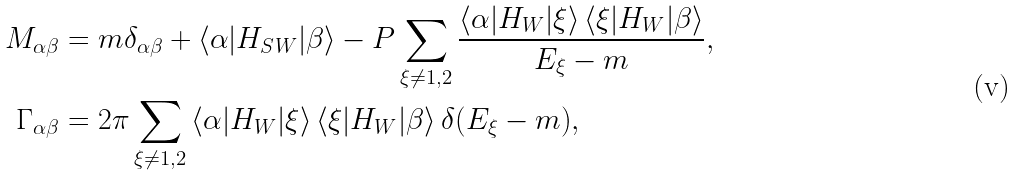<formula> <loc_0><loc_0><loc_500><loc_500>M _ { \alpha \beta } & = m \delta _ { \alpha \beta } + \left < \alpha | H _ { S W } | \beta \right > - P \sum _ { \xi \neq 1 , 2 } { \frac { \left < \alpha | H _ { W } | \xi \right > \left < \xi | H _ { W } | \beta \right > } { E _ { \xi } - m } } , \\ \Gamma _ { \alpha \beta } & = 2 \pi \sum _ { \xi \neq 1 , 2 } { \left < \alpha | H _ { W } | \xi \right > \left < \xi | H _ { W } | \beta \right > \delta ( E _ { \xi } - m ) } ,</formula> 